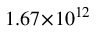Convert formula to latex. <formula><loc_0><loc_0><loc_500><loc_500>1 . 6 7 \, \times \, 1 0 ^ { 1 2 }</formula> 